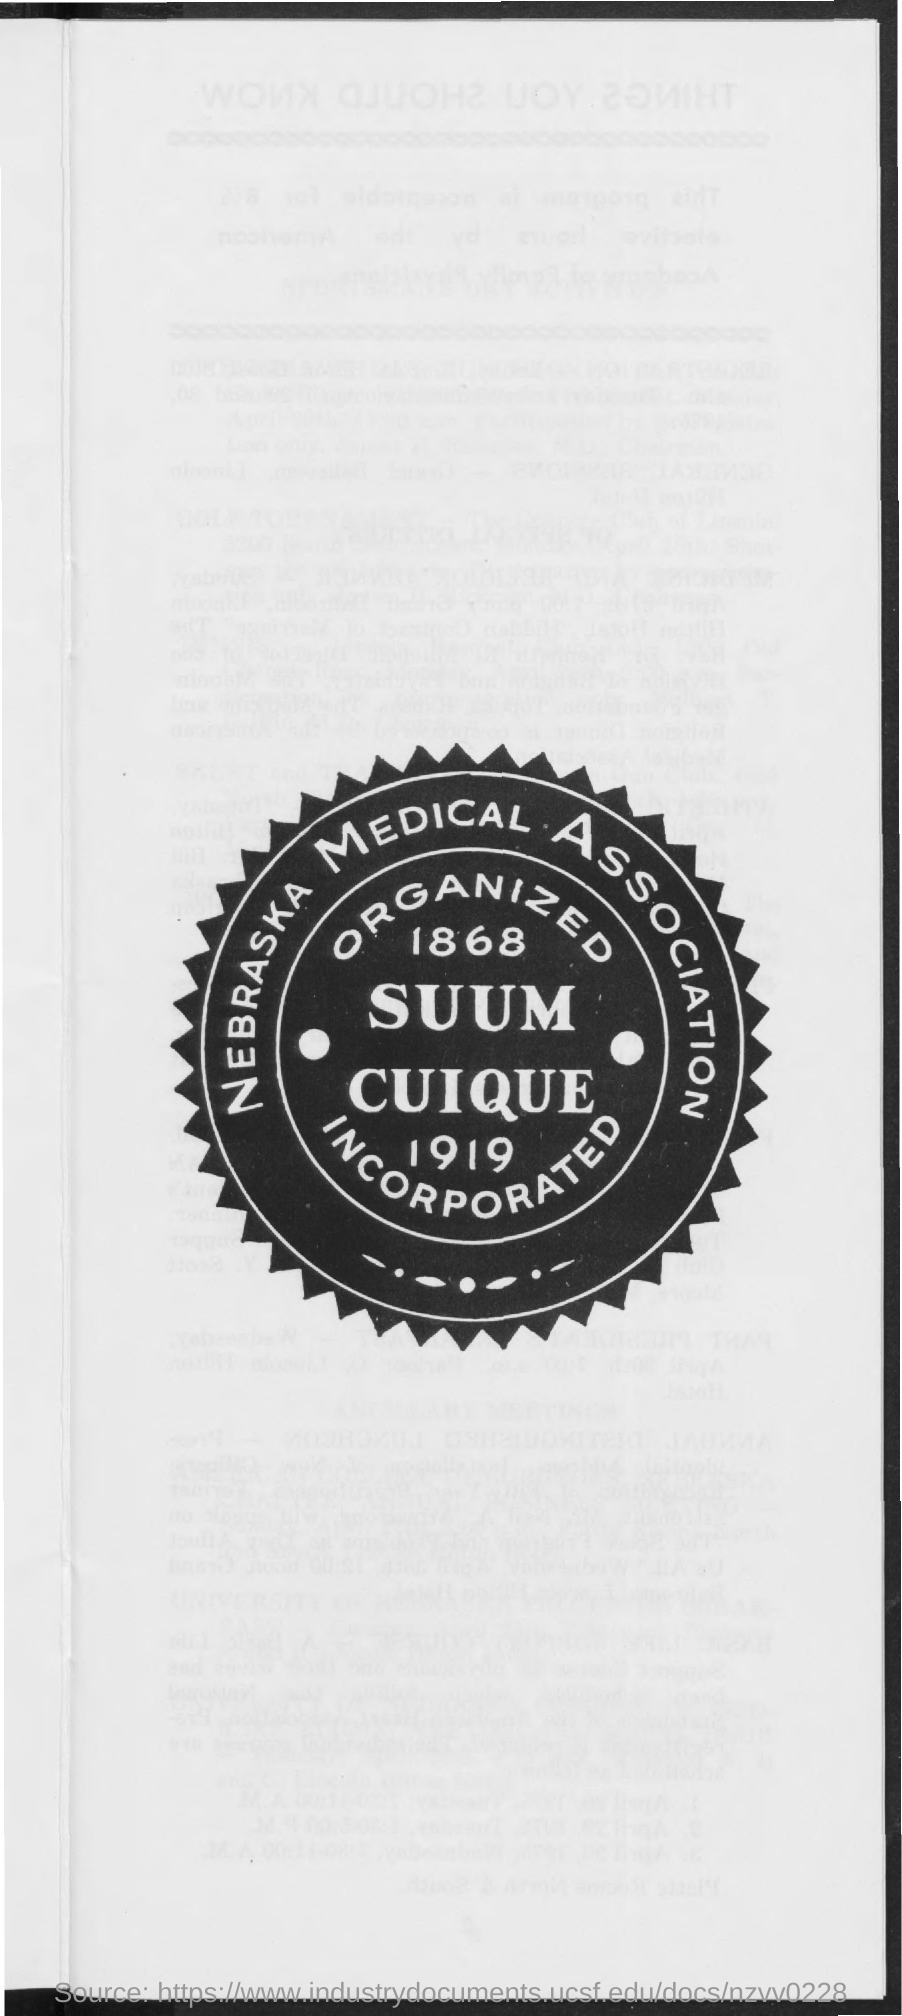Highlight a few significant elements in this photo. The Nebraska Medical Association is the association in question. 